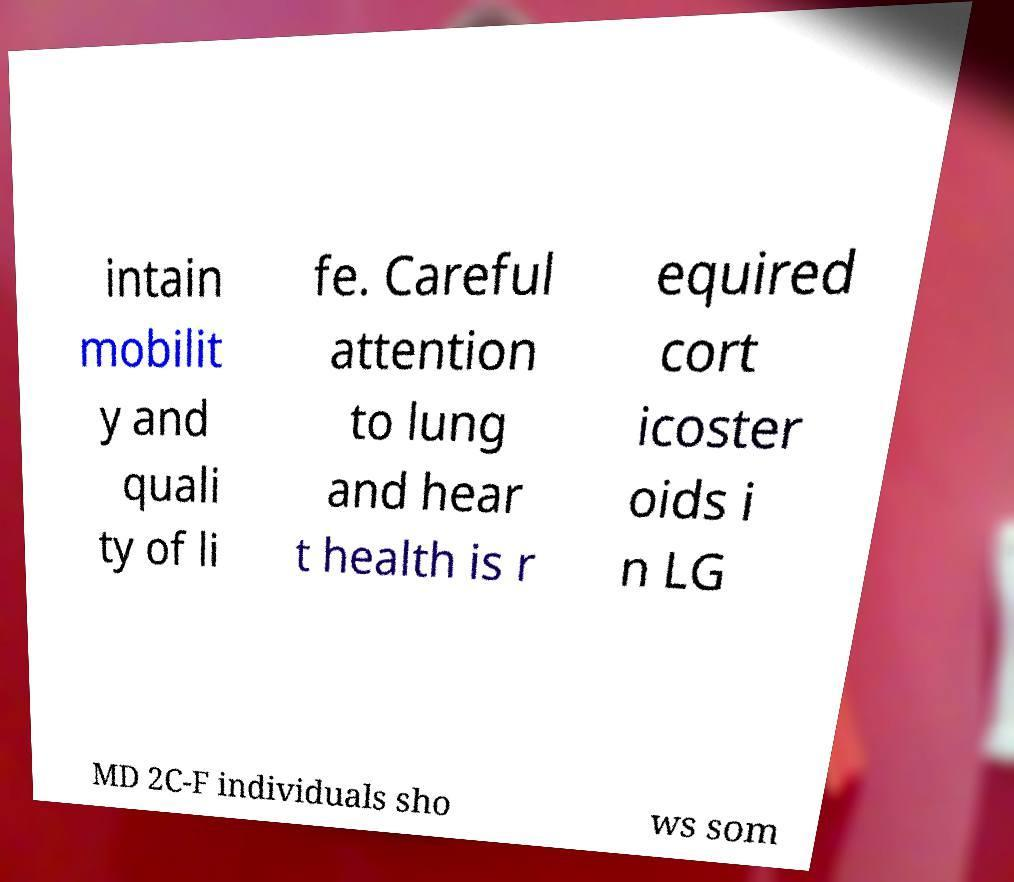Can you read and provide the text displayed in the image?This photo seems to have some interesting text. Can you extract and type it out for me? intain mobilit y and quali ty of li fe. Careful attention to lung and hear t health is r equired cort icoster oids i n LG MD 2C-F individuals sho ws som 